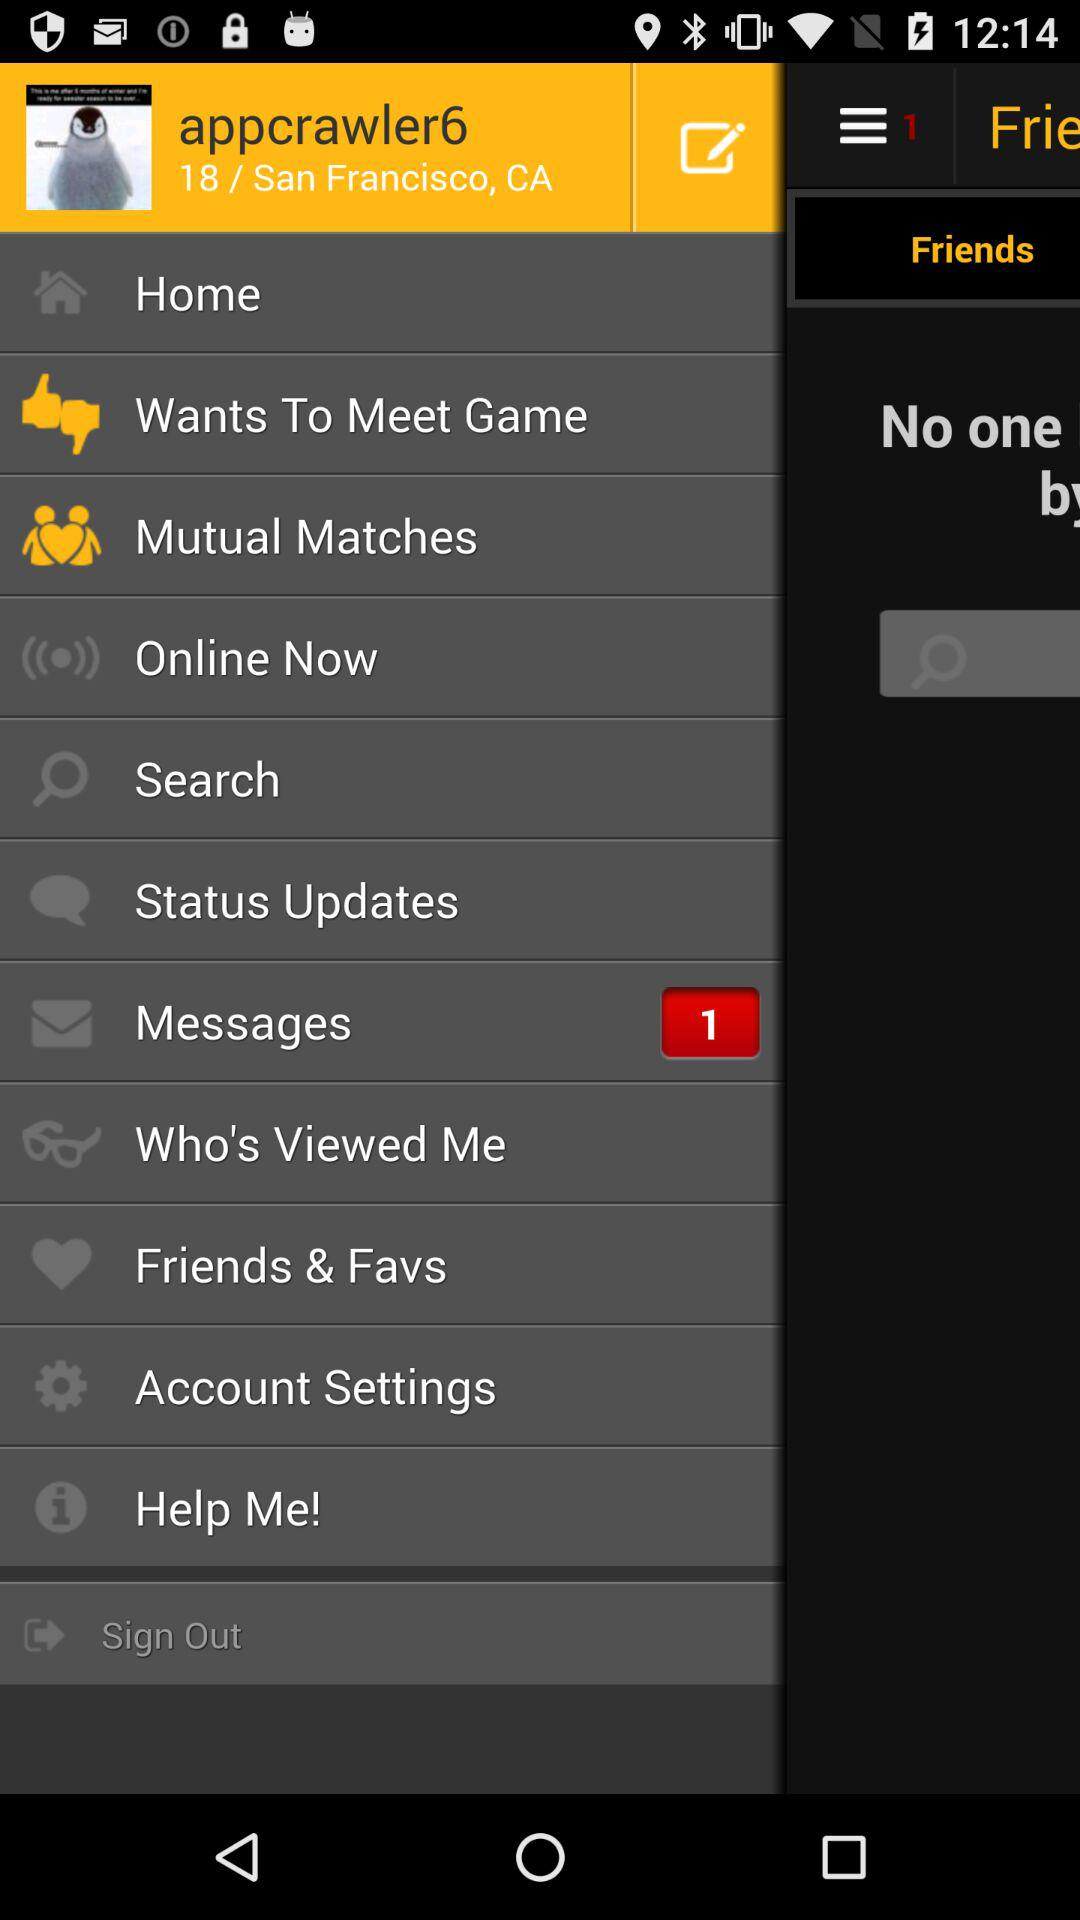What is the profile name? The profile name is "appcrawler6". 